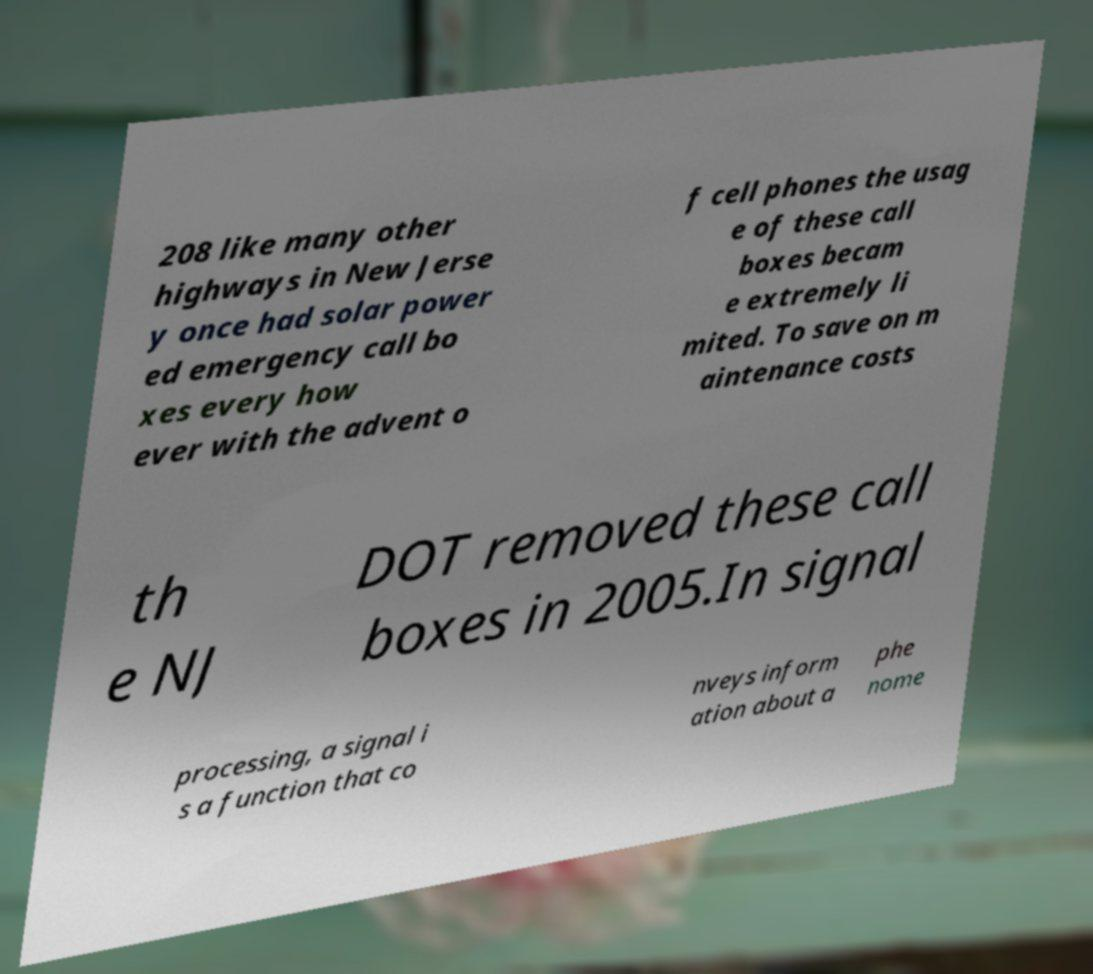Can you accurately transcribe the text from the provided image for me? 208 like many other highways in New Jerse y once had solar power ed emergency call bo xes every how ever with the advent o f cell phones the usag e of these call boxes becam e extremely li mited. To save on m aintenance costs th e NJ DOT removed these call boxes in 2005.In signal processing, a signal i s a function that co nveys inform ation about a phe nome 